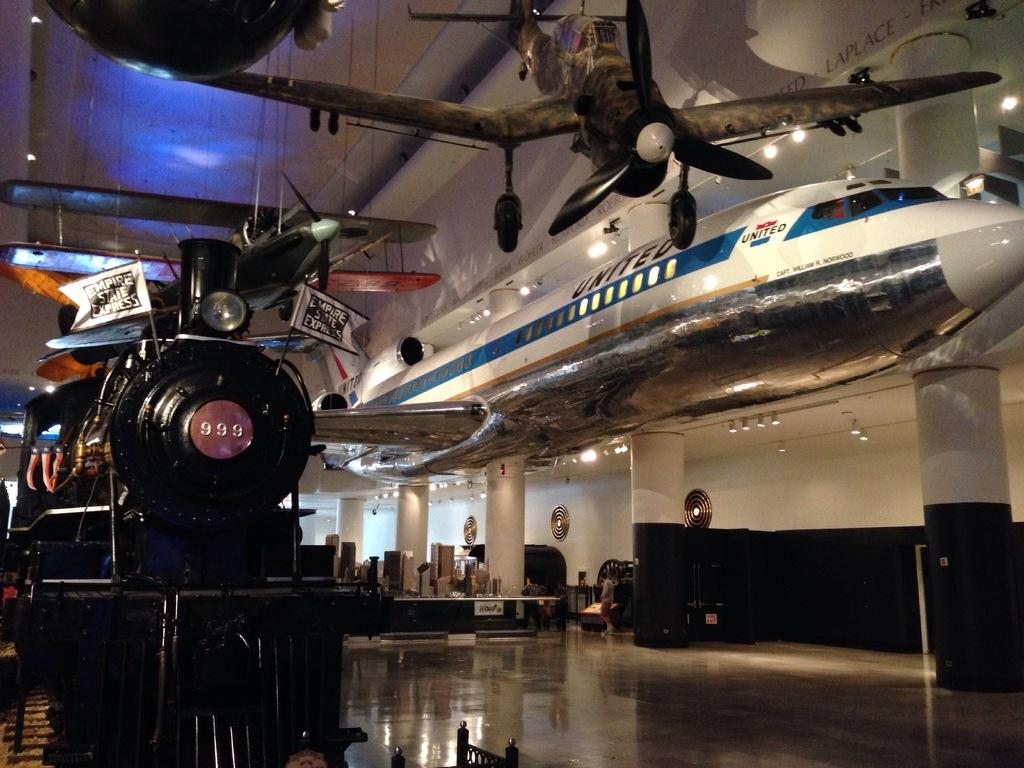Provide a one-sentence caption for the provided image. a museum with a train and an airplane in it. 